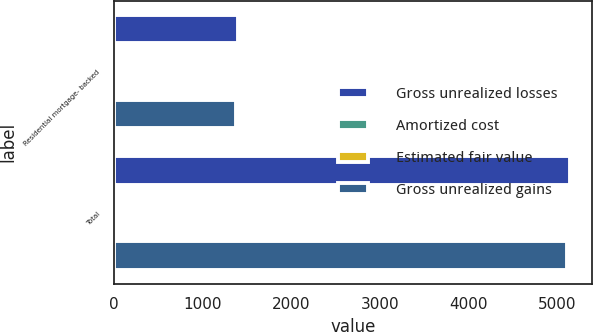<chart> <loc_0><loc_0><loc_500><loc_500><stacked_bar_chart><ecel><fcel>Residential mortgage- backed<fcel>Total<nl><fcel>Gross unrealized losses<fcel>1400<fcel>5138<nl><fcel>Amortized cost<fcel>2<fcel>3<nl><fcel>Estimated fair value<fcel>29<fcel>31<nl><fcel>Gross unrealized gains<fcel>1373<fcel>5110<nl></chart> 